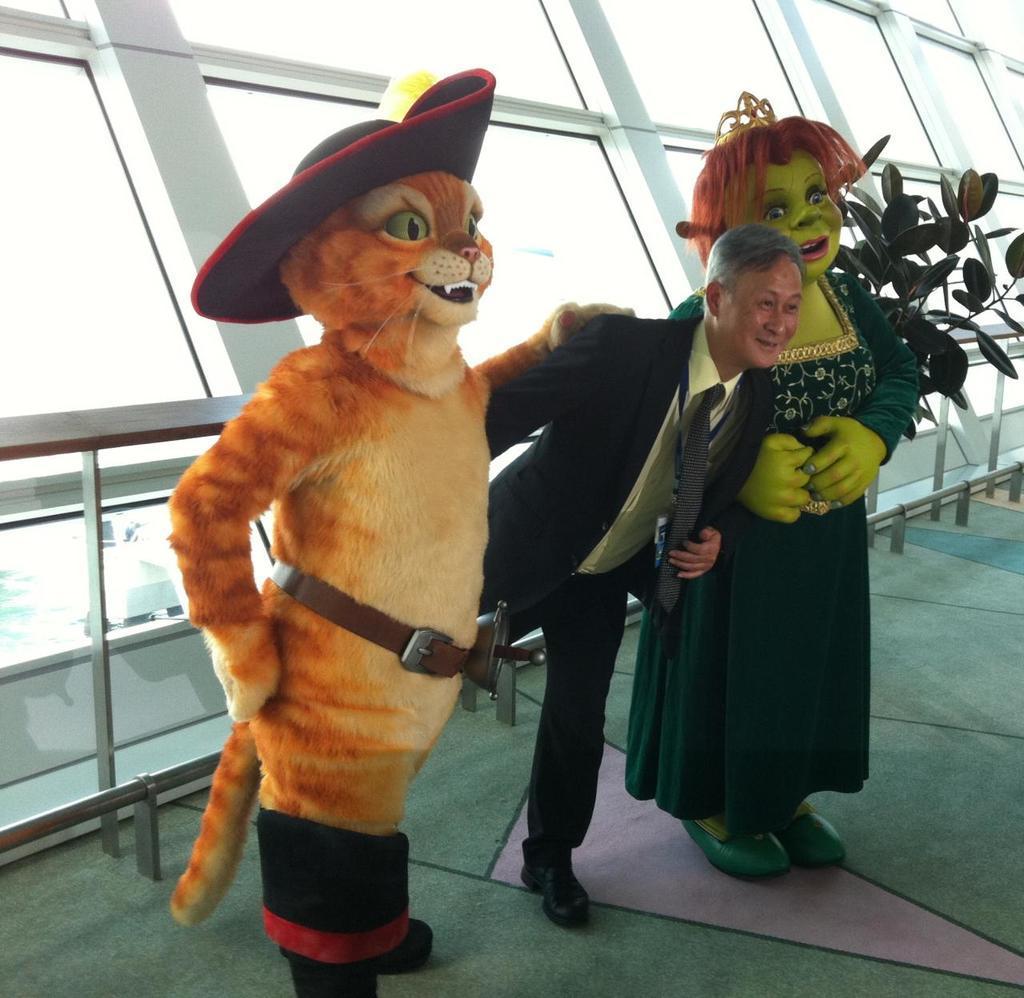Please provide a concise description of this image. In this picture we can see three persons are standing, persons on the right side and left side are wearing costumes, on the right side there is a plant, in the background we can see glasses. 